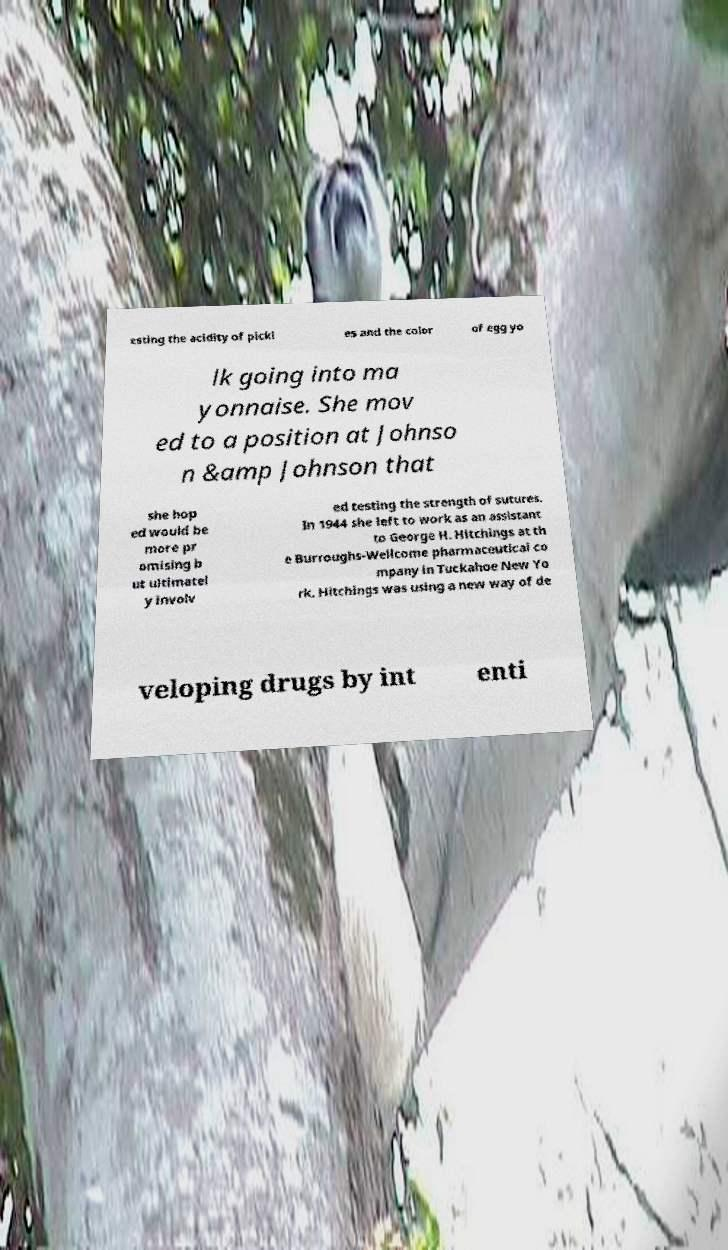Could you extract and type out the text from this image? esting the acidity of pickl es and the color of egg yo lk going into ma yonnaise. She mov ed to a position at Johnso n &amp Johnson that she hop ed would be more pr omising b ut ultimatel y involv ed testing the strength of sutures. In 1944 she left to work as an assistant to George H. Hitchings at th e Burroughs-Wellcome pharmaceutical co mpany in Tuckahoe New Yo rk. Hitchings was using a new way of de veloping drugs by int enti 